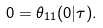Convert formula to latex. <formula><loc_0><loc_0><loc_500><loc_500>0 = \theta _ { 1 1 } ( 0 | \tau ) .</formula> 